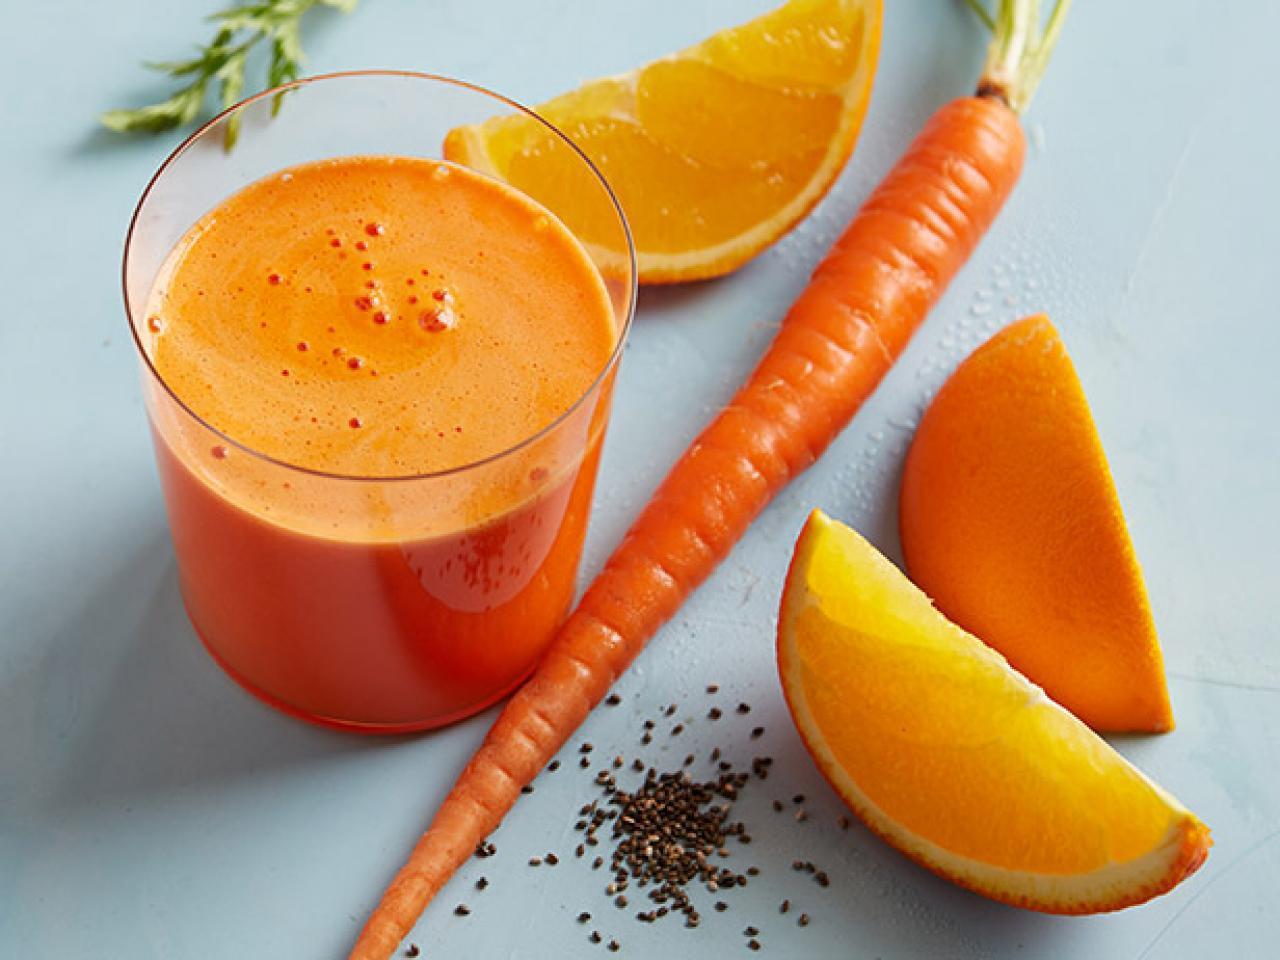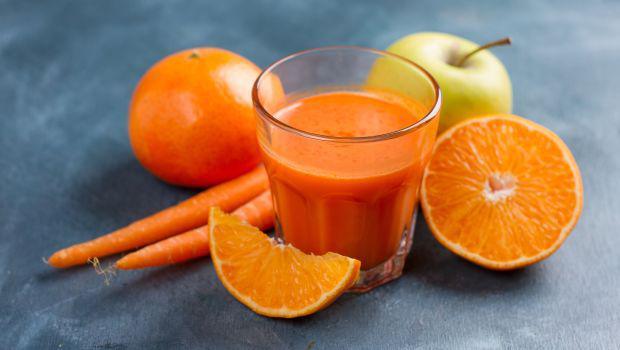The first image is the image on the left, the second image is the image on the right. Examine the images to the left and right. Is the description "In one image, drinks are served in two mason jar glasses, one of them sitting on a cloth napkin, with striped straws." accurate? Answer yes or no. No. The first image is the image on the left, the second image is the image on the right. Examine the images to the left and right. Is the description "An image shows a striped straw in a jar-type beverage glass." accurate? Answer yes or no. No. 